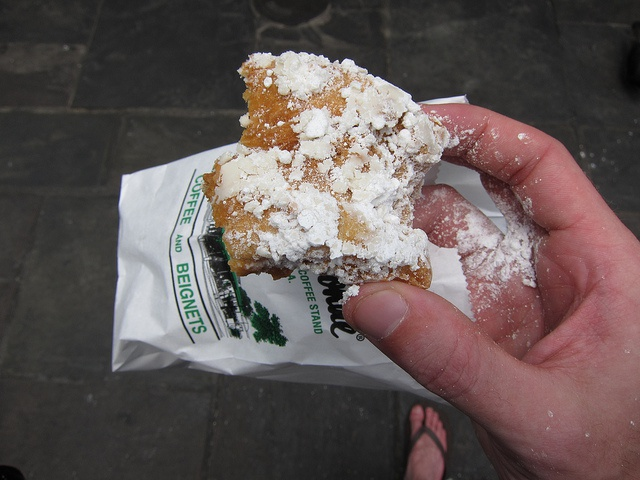Describe the objects in this image and their specific colors. I can see people in black, brown, maroon, and darkgray tones and donut in black, lightgray, darkgray, brown, and gray tones in this image. 